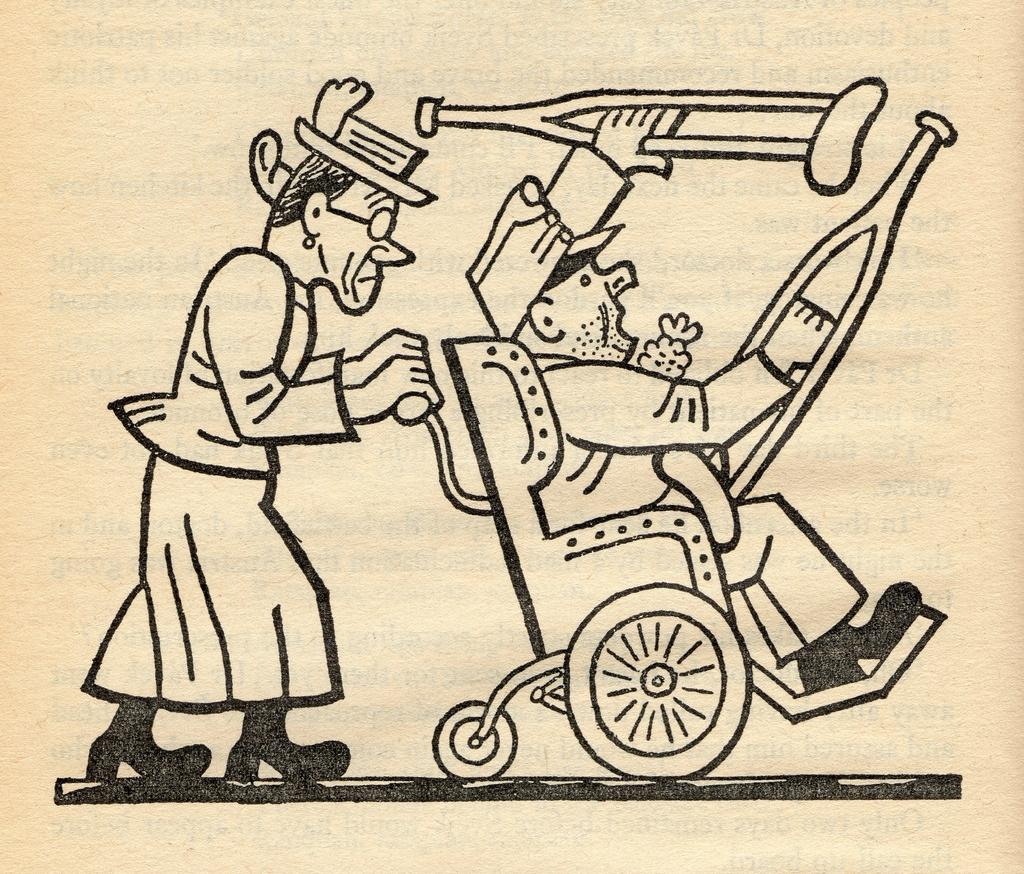What type of images can be seen on the surface in the image? There are cartoon pictures on the surface in the image. Can you see any ants crawling on the cartoon pictures in the image? There are no ants present in the image; it only features cartoon pictures on the surface. Is there a volcano visible in the image? There is no volcano present in the image; it only features cartoon pictures on the surface. 